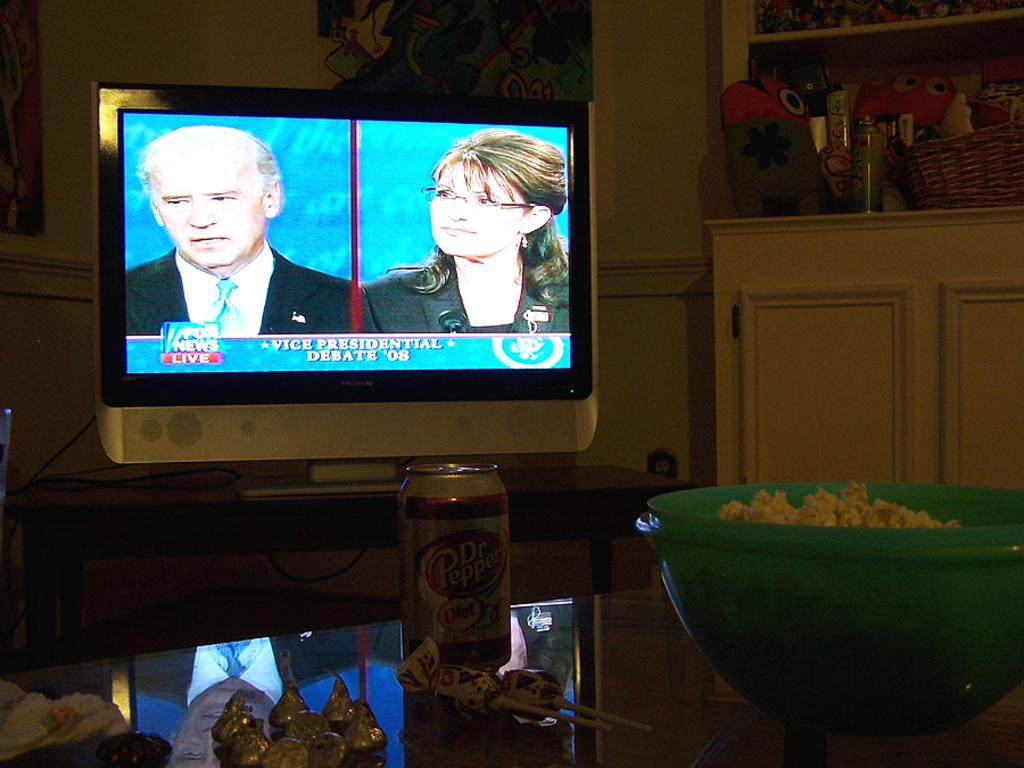<image>
Offer a succinct explanation of the picture presented. a debate on tv where there are people on Fox News 